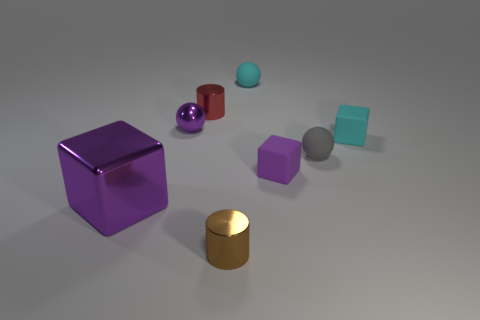Is there a big object that has the same material as the tiny gray object?
Offer a very short reply. No. What size is the red metallic cylinder?
Offer a very short reply. Small. How big is the ball that is on the left side of the cylinder that is behind the brown object?
Your answer should be very brief. Small. What material is the other small thing that is the same shape as the small red thing?
Offer a very short reply. Metal. How many tiny balls are there?
Your answer should be compact. 3. The small metal thing in front of the gray matte object on the right side of the brown object that is in front of the gray rubber object is what color?
Give a very brief answer. Brown. Is the number of red metal things less than the number of small matte objects?
Provide a short and direct response. Yes. The other tiny shiny thing that is the same shape as the red object is what color?
Provide a succinct answer. Brown. The other ball that is the same material as the tiny cyan ball is what color?
Provide a succinct answer. Gray. How many brown cylinders have the same size as the red cylinder?
Your response must be concise. 1. 